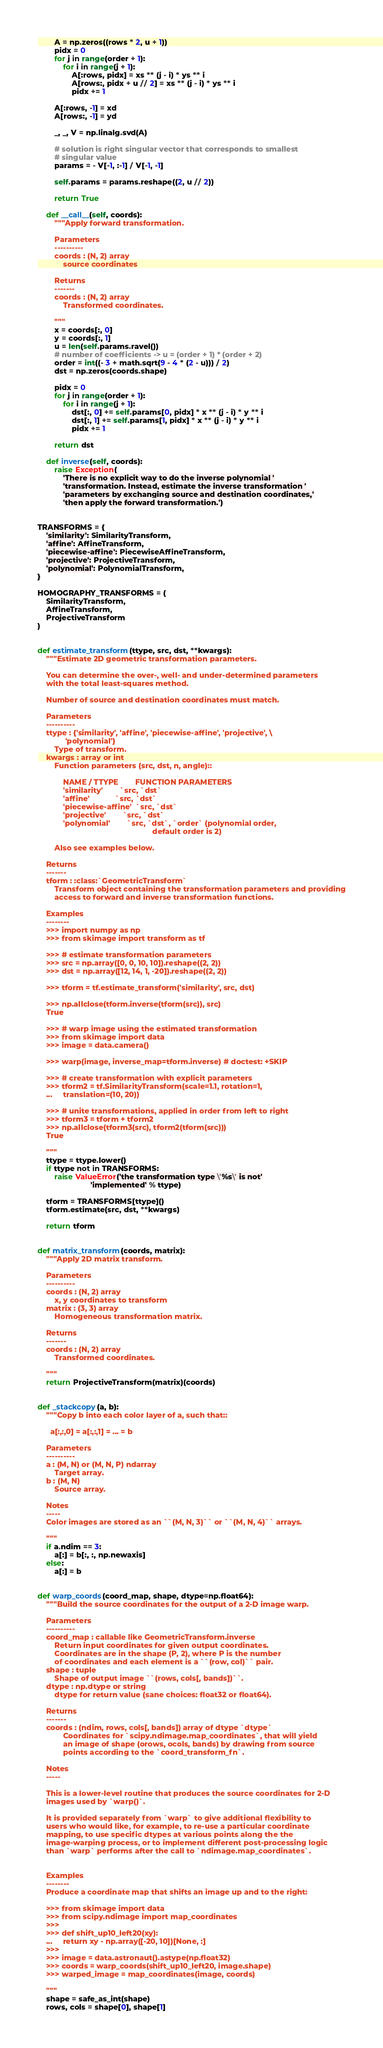Convert code to text. <code><loc_0><loc_0><loc_500><loc_500><_Python_>
        A = np.zeros((rows * 2, u + 1))
        pidx = 0
        for j in range(order + 1):
            for i in range(j + 1):
                A[:rows, pidx] = xs ** (j - i) * ys ** i
                A[rows:, pidx + u // 2] = xs ** (j - i) * ys ** i
                pidx += 1

        A[:rows, -1] = xd
        A[rows:, -1] = yd

        _, _, V = np.linalg.svd(A)

        # solution is right singular vector that corresponds to smallest
        # singular value
        params = - V[-1, :-1] / V[-1, -1]

        self.params = params.reshape((2, u // 2))

        return True

    def __call__(self, coords):
        """Apply forward transformation.

        Parameters
        ----------
        coords : (N, 2) array
            source coordinates

        Returns
        -------
        coords : (N, 2) array
            Transformed coordinates.

        """
        x = coords[:, 0]
        y = coords[:, 1]
        u = len(self.params.ravel())
        # number of coefficients -> u = (order + 1) * (order + 2)
        order = int((- 3 + math.sqrt(9 - 4 * (2 - u))) / 2)
        dst = np.zeros(coords.shape)

        pidx = 0
        for j in range(order + 1):
            for i in range(j + 1):
                dst[:, 0] += self.params[0, pidx] * x ** (j - i) * y ** i
                dst[:, 1] += self.params[1, pidx] * x ** (j - i) * y ** i
                pidx += 1

        return dst

    def inverse(self, coords):
        raise Exception(
            'There is no explicit way to do the inverse polynomial '
            'transformation. Instead, estimate the inverse transformation '
            'parameters by exchanging source and destination coordinates,'
            'then apply the forward transformation.')


TRANSFORMS = {
    'similarity': SimilarityTransform,
    'affine': AffineTransform,
    'piecewise-affine': PiecewiseAffineTransform,
    'projective': ProjectiveTransform,
    'polynomial': PolynomialTransform,
}

HOMOGRAPHY_TRANSFORMS = (
    SimilarityTransform,
    AffineTransform,
    ProjectiveTransform
)


def estimate_transform(ttype, src, dst, **kwargs):
    """Estimate 2D geometric transformation parameters.

    You can determine the over-, well- and under-determined parameters
    with the total least-squares method.

    Number of source and destination coordinates must match.

    Parameters
    ----------
    ttype : {'similarity', 'affine', 'piecewise-affine', 'projective', \
             'polynomial'}
        Type of transform.
    kwargs : array or int
        Function parameters (src, dst, n, angle)::

            NAME / TTYPE        FUNCTION PARAMETERS
            'similarity'        `src, `dst`
            'affine'            `src, `dst`
            'piecewise-affine'  `src, `dst`
            'projective'        `src, `dst`
            'polynomial'        `src, `dst`, `order` (polynomial order,
                                                      default order is 2)

        Also see examples below.

    Returns
    -------
    tform : :class:`GeometricTransform`
        Transform object containing the transformation parameters and providing
        access to forward and inverse transformation functions.

    Examples
    --------
    >>> import numpy as np
    >>> from skimage import transform as tf

    >>> # estimate transformation parameters
    >>> src = np.array([0, 0, 10, 10]).reshape((2, 2))
    >>> dst = np.array([12, 14, 1, -20]).reshape((2, 2))

    >>> tform = tf.estimate_transform('similarity', src, dst)

    >>> np.allclose(tform.inverse(tform(src)), src)
    True

    >>> # warp image using the estimated transformation
    >>> from skimage import data
    >>> image = data.camera()

    >>> warp(image, inverse_map=tform.inverse) # doctest: +SKIP

    >>> # create transformation with explicit parameters
    >>> tform2 = tf.SimilarityTransform(scale=1.1, rotation=1,
    ...     translation=(10, 20))

    >>> # unite transformations, applied in order from left to right
    >>> tform3 = tform + tform2
    >>> np.allclose(tform3(src), tform2(tform(src)))
    True

    """
    ttype = ttype.lower()
    if ttype not in TRANSFORMS:
        raise ValueError('the transformation type \'%s\' is not'
                         'implemented' % ttype)

    tform = TRANSFORMS[ttype]()
    tform.estimate(src, dst, **kwargs)

    return tform


def matrix_transform(coords, matrix):
    """Apply 2D matrix transform.

    Parameters
    ----------
    coords : (N, 2) array
        x, y coordinates to transform
    matrix : (3, 3) array
        Homogeneous transformation matrix.

    Returns
    -------
    coords : (N, 2) array
        Transformed coordinates.

    """
    return ProjectiveTransform(matrix)(coords)


def _stackcopy(a, b):
    """Copy b into each color layer of a, such that::

      a[:,:,0] = a[:,:,1] = ... = b

    Parameters
    ----------
    a : (M, N) or (M, N, P) ndarray
        Target array.
    b : (M, N)
        Source array.

    Notes
    -----
    Color images are stored as an ``(M, N, 3)`` or ``(M, N, 4)`` arrays.

    """
    if a.ndim == 3:
        a[:] = b[:, :, np.newaxis]
    else:
        a[:] = b


def warp_coords(coord_map, shape, dtype=np.float64):
    """Build the source coordinates for the output of a 2-D image warp.

    Parameters
    ----------
    coord_map : callable like GeometricTransform.inverse
        Return input coordinates for given output coordinates.
        Coordinates are in the shape (P, 2), where P is the number
        of coordinates and each element is a ``(row, col)`` pair.
    shape : tuple
        Shape of output image ``(rows, cols[, bands])``.
    dtype : np.dtype or string
        dtype for return value (sane choices: float32 or float64).

    Returns
    -------
    coords : (ndim, rows, cols[, bands]) array of dtype `dtype`
            Coordinates for `scipy.ndimage.map_coordinates`, that will yield
            an image of shape (orows, ocols, bands) by drawing from source
            points according to the `coord_transform_fn`.

    Notes
    -----

    This is a lower-level routine that produces the source coordinates for 2-D
    images used by `warp()`.

    It is provided separately from `warp` to give additional flexibility to
    users who would like, for example, to re-use a particular coordinate
    mapping, to use specific dtypes at various points along the the
    image-warping process, or to implement different post-processing logic
    than `warp` performs after the call to `ndimage.map_coordinates`.


    Examples
    --------
    Produce a coordinate map that shifts an image up and to the right:

    >>> from skimage import data
    >>> from scipy.ndimage import map_coordinates
    >>>
    >>> def shift_up10_left20(xy):
    ...     return xy - np.array([-20, 10])[None, :]
    >>>
    >>> image = data.astronaut().astype(np.float32)
    >>> coords = warp_coords(shift_up10_left20, image.shape)
    >>> warped_image = map_coordinates(image, coords)

    """
    shape = safe_as_int(shape)
    rows, cols = shape[0], shape[1]</code> 